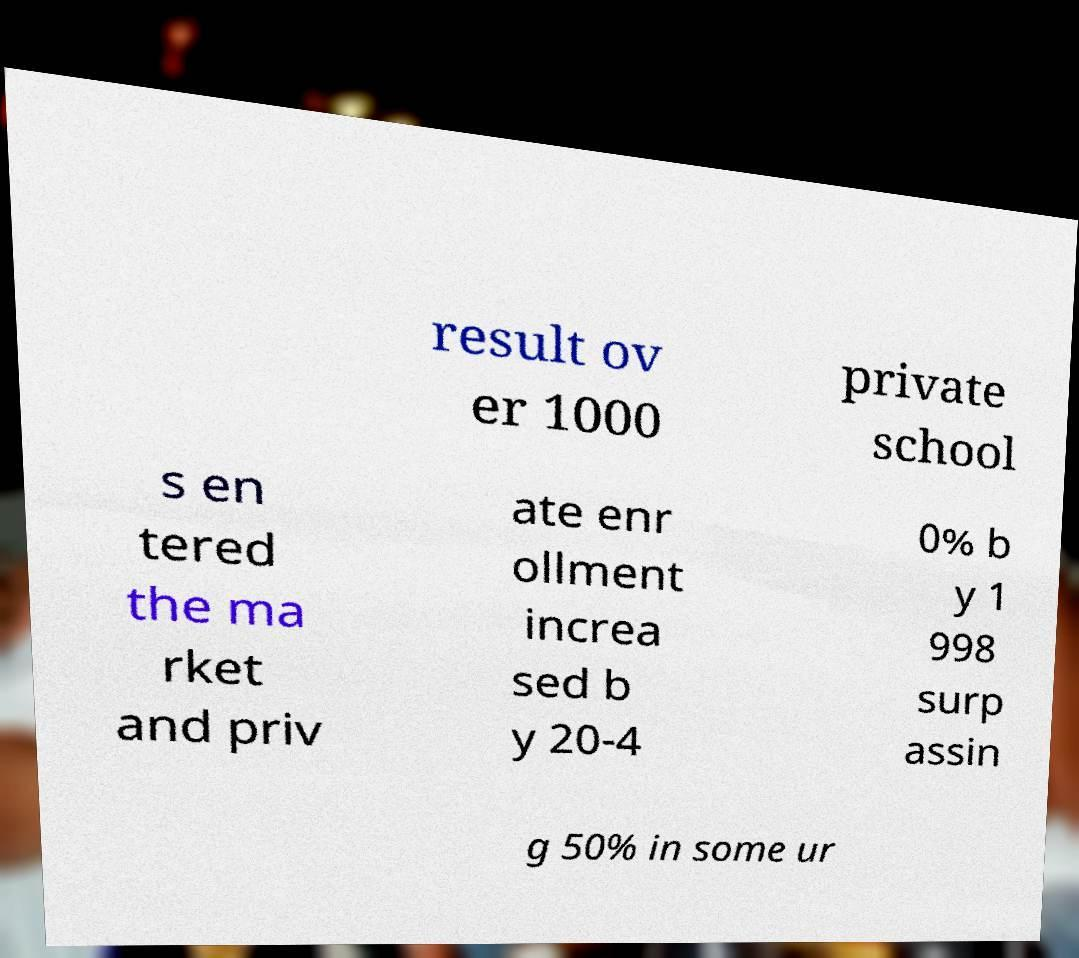Please identify and transcribe the text found in this image. result ov er 1000 private school s en tered the ma rket and priv ate enr ollment increa sed b y 20-4 0% b y 1 998 surp assin g 50% in some ur 